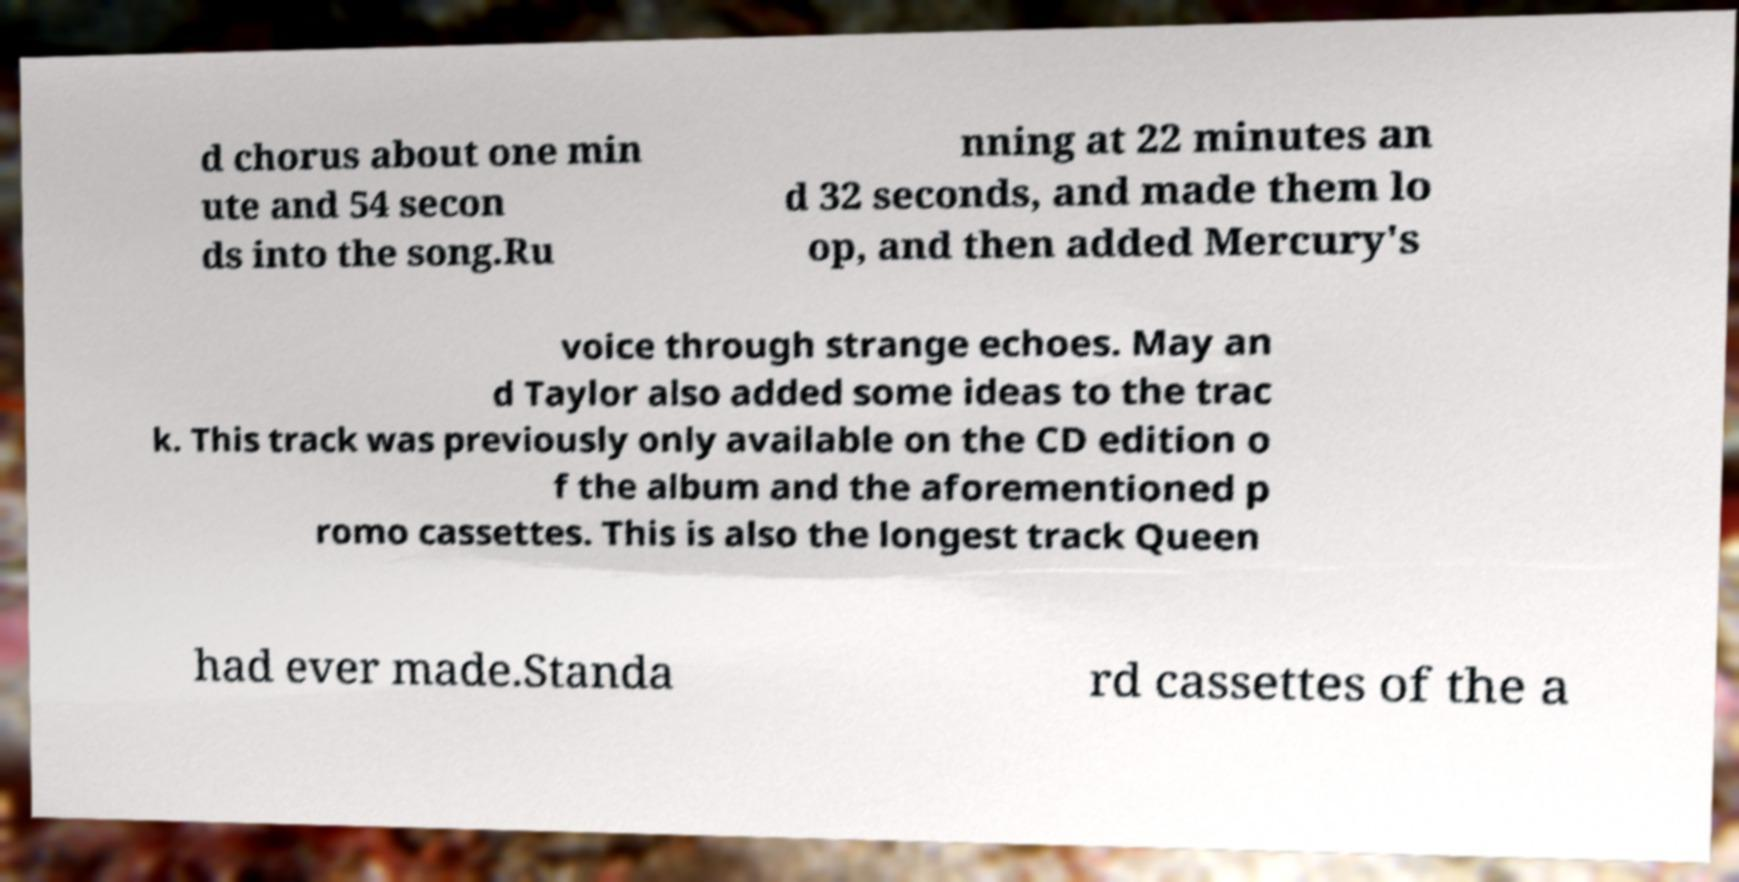There's text embedded in this image that I need extracted. Can you transcribe it verbatim? d chorus about one min ute and 54 secon ds into the song.Ru nning at 22 minutes an d 32 seconds, and made them lo op, and then added Mercury's voice through strange echoes. May an d Taylor also added some ideas to the trac k. This track was previously only available on the CD edition o f the album and the aforementioned p romo cassettes. This is also the longest track Queen had ever made.Standa rd cassettes of the a 